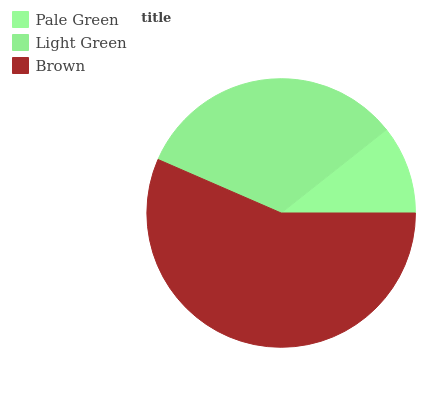Is Pale Green the minimum?
Answer yes or no. Yes. Is Brown the maximum?
Answer yes or no. Yes. Is Light Green the minimum?
Answer yes or no. No. Is Light Green the maximum?
Answer yes or no. No. Is Light Green greater than Pale Green?
Answer yes or no. Yes. Is Pale Green less than Light Green?
Answer yes or no. Yes. Is Pale Green greater than Light Green?
Answer yes or no. No. Is Light Green less than Pale Green?
Answer yes or no. No. Is Light Green the high median?
Answer yes or no. Yes. Is Light Green the low median?
Answer yes or no. Yes. Is Brown the high median?
Answer yes or no. No. Is Brown the low median?
Answer yes or no. No. 